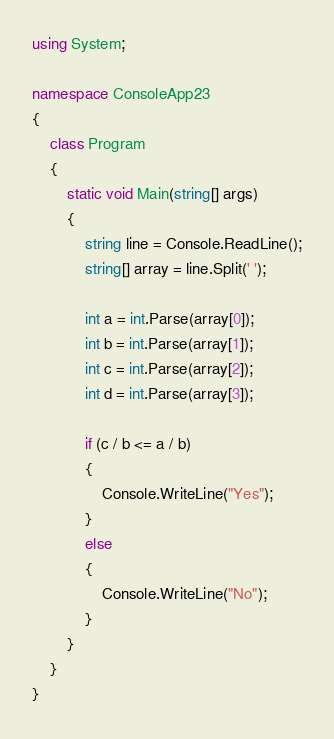<code> <loc_0><loc_0><loc_500><loc_500><_C#_>using System;

namespace ConsoleApp23
{
    class Program
    {
        static void Main(string[] args)
        {
            string line = Console.ReadLine();
            string[] array = line.Split(' ');
            
            int a = int.Parse(array[0]);           
            int b = int.Parse(array[1]);
            int c = int.Parse(array[2]);
            int d = int.Parse(array[3]);

            if (c / b <= a / b)
            {
                Console.WriteLine("Yes");
            }
            else
            {
                Console.WriteLine("No");
            }
        }
    }
}
</code> 